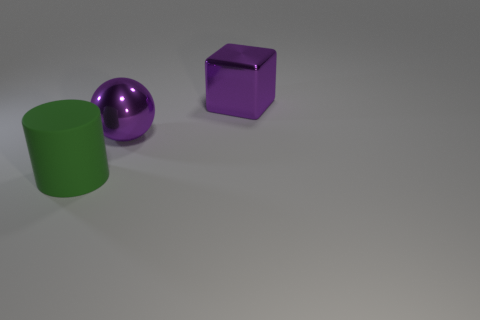Add 3 small brown cubes. How many objects exist? 6 Subtract all cylinders. How many objects are left? 2 Add 3 large purple balls. How many large purple balls are left? 4 Add 3 blue shiny cubes. How many blue shiny cubes exist? 3 Subtract 1 purple balls. How many objects are left? 2 Subtract all cylinders. Subtract all big purple blocks. How many objects are left? 1 